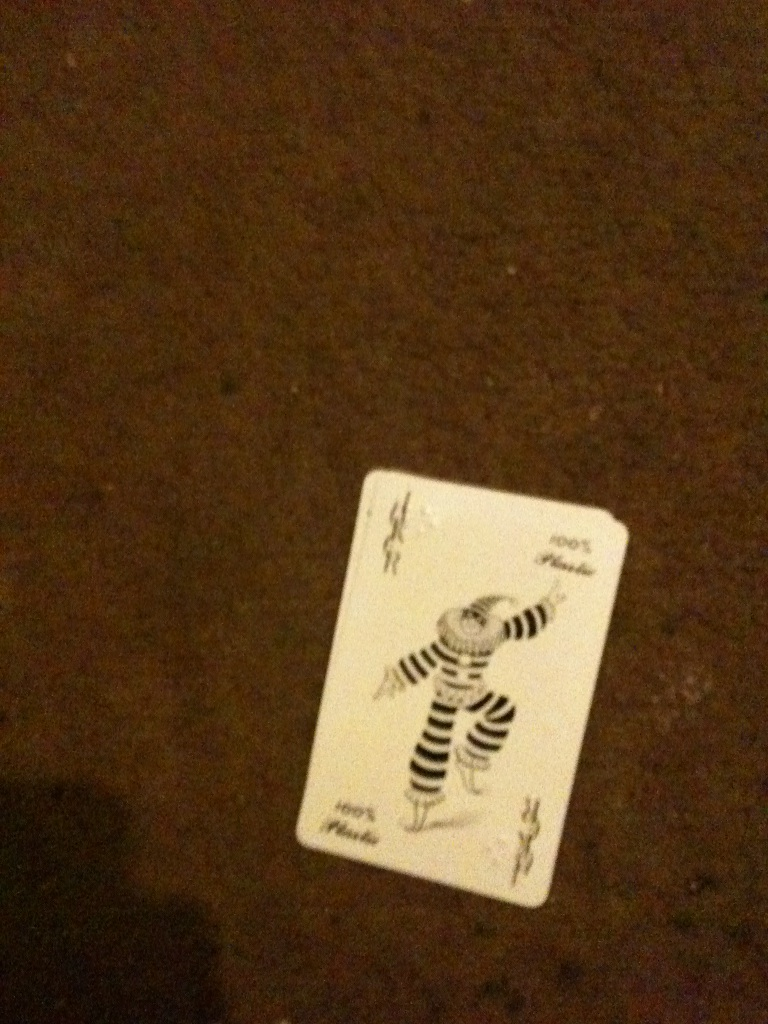Write an in-depth analysis of the artistic aspects of this Joker card. This Joker card features a highly stylized illustration of a whimsical character dressed in black and white striped attire. The use of vertical and horizontal stripes creates a sense of movement and dynamism, while the exaggerated pose of the character suggests playfulness and a penchant for mischief. The artist has chosen to keep the design relatively minimalistic with a limited color palette, focusing instead on the fluidity of the line work and the expressiveness of the figure's stance. The figure's headpiece, reminiscent of a traditional jester hat, anchors the character in historical and cultural contexts, harking back to the era where jesters were essential elements of court entertainment. Additionally, the small, almost hidden details like the miniature jester figures in the corners add depth and invite closer inspection, making the card a piece of art that's both visually engaging and narratively rich. 